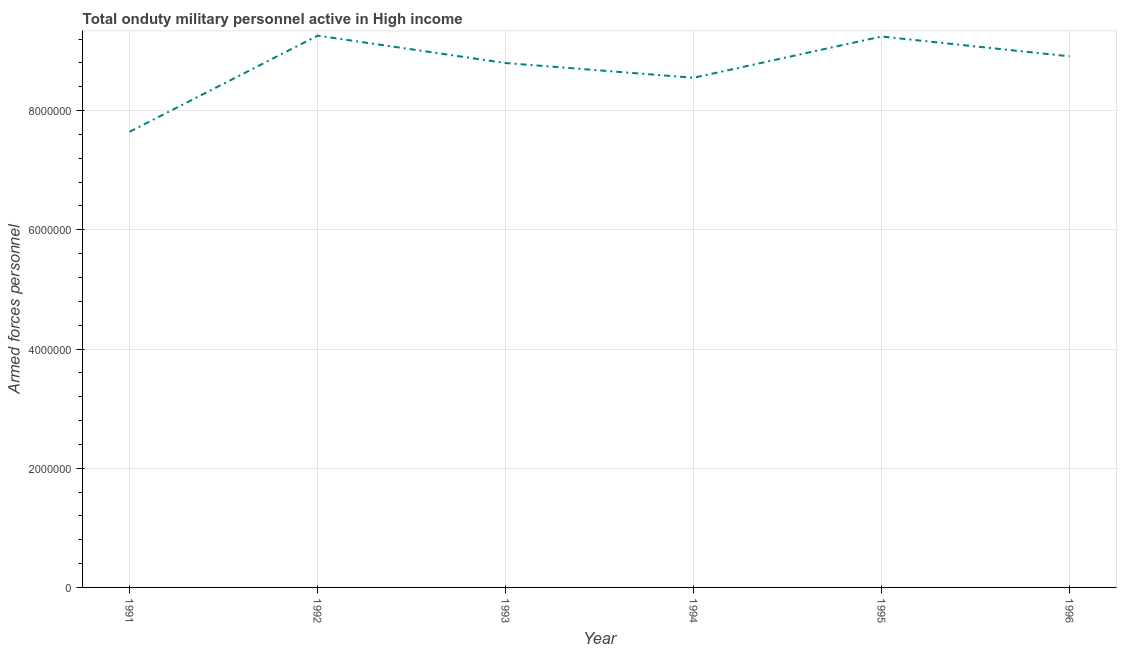What is the number of armed forces personnel in 1996?
Your answer should be very brief. 8.91e+06. Across all years, what is the maximum number of armed forces personnel?
Your answer should be very brief. 9.26e+06. Across all years, what is the minimum number of armed forces personnel?
Offer a terse response. 7.65e+06. In which year was the number of armed forces personnel maximum?
Your answer should be compact. 1992. In which year was the number of armed forces personnel minimum?
Offer a very short reply. 1991. What is the sum of the number of armed forces personnel?
Make the answer very short. 5.24e+07. What is the difference between the number of armed forces personnel in 1992 and 1995?
Your answer should be very brief. 1.49e+04. What is the average number of armed forces personnel per year?
Your answer should be very brief. 8.73e+06. What is the median number of armed forces personnel?
Keep it short and to the point. 8.85e+06. In how many years, is the number of armed forces personnel greater than 8400000 ?
Make the answer very short. 5. Do a majority of the years between 1995 and 1991 (inclusive) have number of armed forces personnel greater than 1200000 ?
Make the answer very short. Yes. What is the ratio of the number of armed forces personnel in 1992 to that in 1995?
Give a very brief answer. 1. What is the difference between the highest and the second highest number of armed forces personnel?
Offer a terse response. 1.49e+04. Is the sum of the number of armed forces personnel in 1992 and 1994 greater than the maximum number of armed forces personnel across all years?
Your response must be concise. Yes. What is the difference between the highest and the lowest number of armed forces personnel?
Your answer should be very brief. 1.61e+06. How many lines are there?
Provide a succinct answer. 1. Are the values on the major ticks of Y-axis written in scientific E-notation?
Offer a terse response. No. Does the graph contain any zero values?
Offer a very short reply. No. Does the graph contain grids?
Your answer should be very brief. Yes. What is the title of the graph?
Make the answer very short. Total onduty military personnel active in High income. What is the label or title of the Y-axis?
Give a very brief answer. Armed forces personnel. What is the Armed forces personnel in 1991?
Offer a terse response. 7.65e+06. What is the Armed forces personnel of 1992?
Give a very brief answer. 9.26e+06. What is the Armed forces personnel in 1993?
Your answer should be compact. 8.80e+06. What is the Armed forces personnel of 1994?
Make the answer very short. 8.55e+06. What is the Armed forces personnel of 1995?
Your response must be concise. 9.24e+06. What is the Armed forces personnel of 1996?
Provide a succinct answer. 8.91e+06. What is the difference between the Armed forces personnel in 1991 and 1992?
Offer a terse response. -1.61e+06. What is the difference between the Armed forces personnel in 1991 and 1993?
Your answer should be compact. -1.15e+06. What is the difference between the Armed forces personnel in 1991 and 1994?
Make the answer very short. -9.05e+05. What is the difference between the Armed forces personnel in 1991 and 1995?
Your response must be concise. -1.60e+06. What is the difference between the Armed forces personnel in 1991 and 1996?
Your answer should be compact. -1.26e+06. What is the difference between the Armed forces personnel in 1992 and 1994?
Provide a short and direct response. 7.07e+05. What is the difference between the Armed forces personnel in 1992 and 1995?
Keep it short and to the point. 1.49e+04. What is the difference between the Armed forces personnel in 1992 and 1996?
Offer a terse response. 3.47e+05. What is the difference between the Armed forces personnel in 1993 and 1994?
Ensure brevity in your answer.  2.47e+05. What is the difference between the Armed forces personnel in 1993 and 1995?
Keep it short and to the point. -4.45e+05. What is the difference between the Armed forces personnel in 1993 and 1996?
Make the answer very short. -1.13e+05. What is the difference between the Armed forces personnel in 1994 and 1995?
Offer a terse response. -6.92e+05. What is the difference between the Armed forces personnel in 1994 and 1996?
Your answer should be very brief. -3.60e+05. What is the difference between the Armed forces personnel in 1995 and 1996?
Ensure brevity in your answer.  3.32e+05. What is the ratio of the Armed forces personnel in 1991 to that in 1992?
Your answer should be compact. 0.83. What is the ratio of the Armed forces personnel in 1991 to that in 1993?
Your answer should be very brief. 0.87. What is the ratio of the Armed forces personnel in 1991 to that in 1994?
Your answer should be very brief. 0.89. What is the ratio of the Armed forces personnel in 1991 to that in 1995?
Offer a terse response. 0.83. What is the ratio of the Armed forces personnel in 1991 to that in 1996?
Your response must be concise. 0.86. What is the ratio of the Armed forces personnel in 1992 to that in 1993?
Keep it short and to the point. 1.05. What is the ratio of the Armed forces personnel in 1992 to that in 1994?
Provide a succinct answer. 1.08. What is the ratio of the Armed forces personnel in 1992 to that in 1995?
Provide a succinct answer. 1. What is the ratio of the Armed forces personnel in 1992 to that in 1996?
Provide a short and direct response. 1.04. What is the ratio of the Armed forces personnel in 1994 to that in 1995?
Provide a short and direct response. 0.93. What is the ratio of the Armed forces personnel in 1994 to that in 1996?
Your answer should be compact. 0.96. 